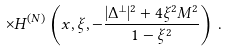<formula> <loc_0><loc_0><loc_500><loc_500>\times H ^ { ( N ) } \left ( x , \xi , - \frac { | \Delta ^ { \perp } | ^ { 2 } + 4 \xi ^ { 2 } M ^ { 2 } } { 1 - \xi ^ { 2 } } \right ) \, .</formula> 